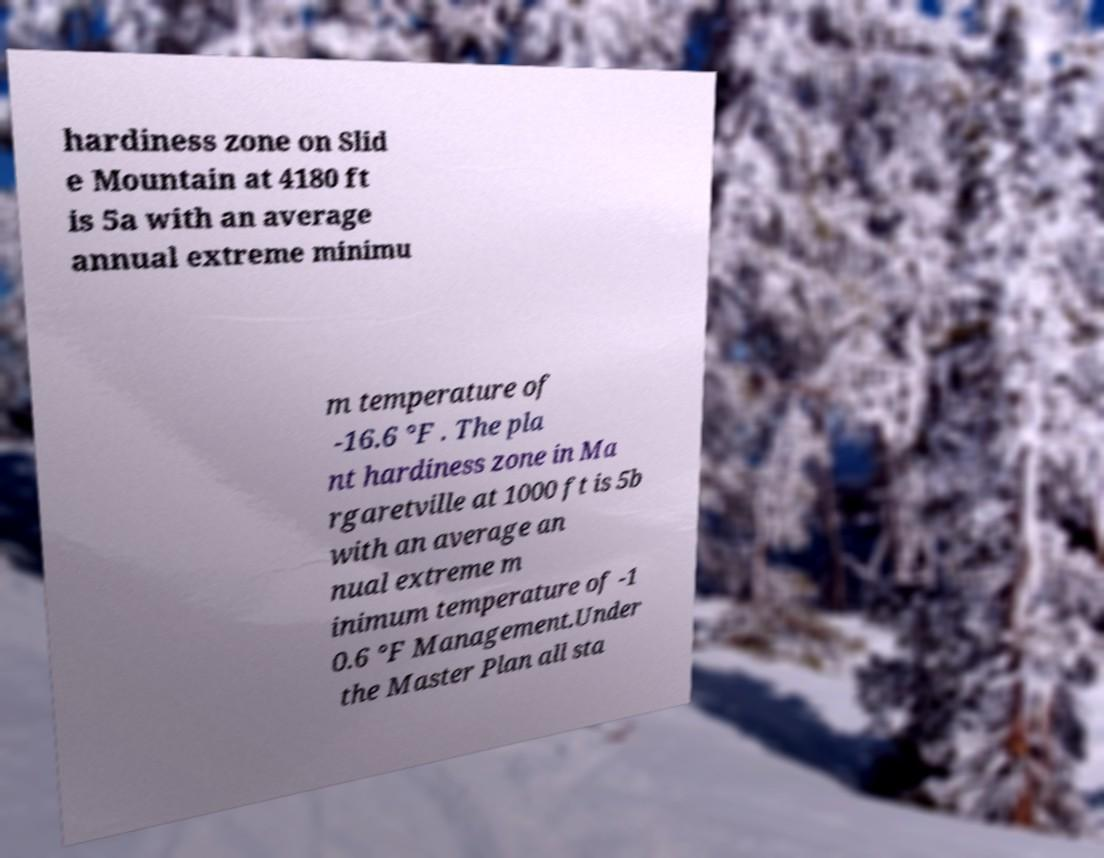Please read and relay the text visible in this image. What does it say? hardiness zone on Slid e Mountain at 4180 ft is 5a with an average annual extreme minimu m temperature of -16.6 °F . The pla nt hardiness zone in Ma rgaretville at 1000 ft is 5b with an average an nual extreme m inimum temperature of -1 0.6 °F Management.Under the Master Plan all sta 